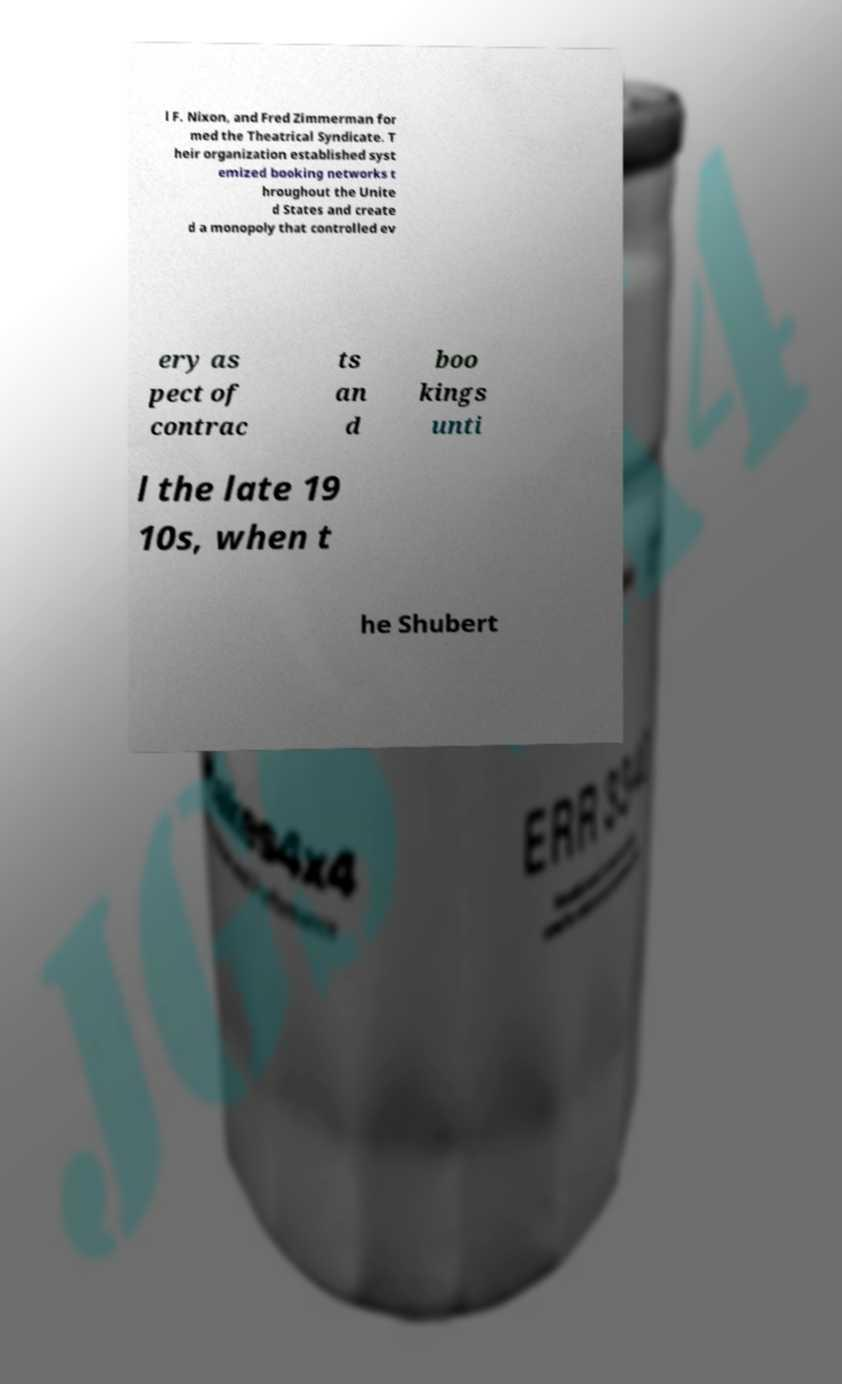What messages or text are displayed in this image? I need them in a readable, typed format. l F. Nixon, and Fred Zimmerman for med the Theatrical Syndicate. T heir organization established syst emized booking networks t hroughout the Unite d States and create d a monopoly that controlled ev ery as pect of contrac ts an d boo kings unti l the late 19 10s, when t he Shubert 